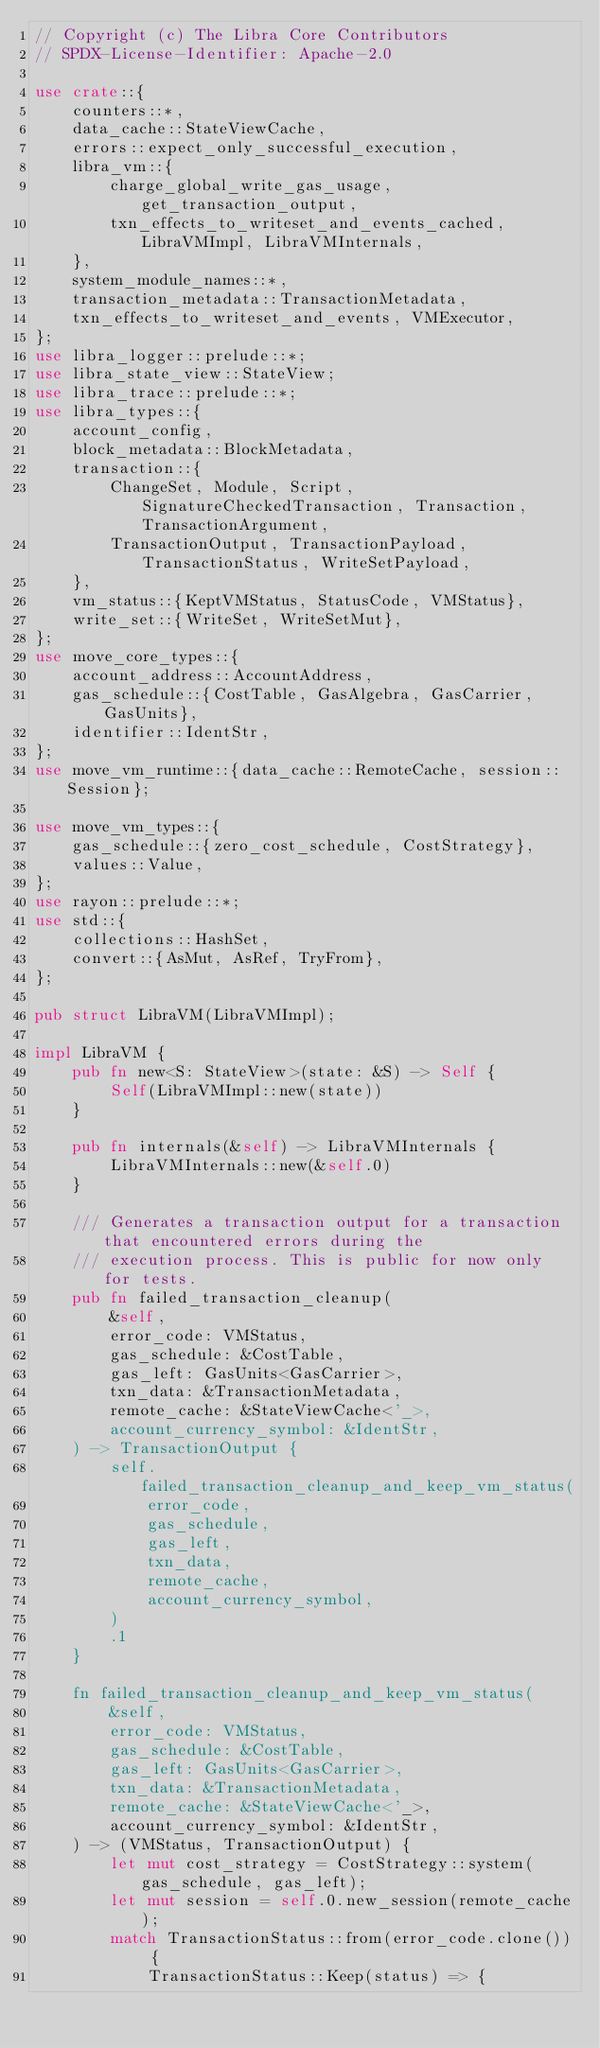Convert code to text. <code><loc_0><loc_0><loc_500><loc_500><_Rust_>// Copyright (c) The Libra Core Contributors
// SPDX-License-Identifier: Apache-2.0

use crate::{
    counters::*,
    data_cache::StateViewCache,
    errors::expect_only_successful_execution,
    libra_vm::{
        charge_global_write_gas_usage, get_transaction_output,
        txn_effects_to_writeset_and_events_cached, LibraVMImpl, LibraVMInternals,
    },
    system_module_names::*,
    transaction_metadata::TransactionMetadata,
    txn_effects_to_writeset_and_events, VMExecutor,
};
use libra_logger::prelude::*;
use libra_state_view::StateView;
use libra_trace::prelude::*;
use libra_types::{
    account_config,
    block_metadata::BlockMetadata,
    transaction::{
        ChangeSet, Module, Script, SignatureCheckedTransaction, Transaction, TransactionArgument,
        TransactionOutput, TransactionPayload, TransactionStatus, WriteSetPayload,
    },
    vm_status::{KeptVMStatus, StatusCode, VMStatus},
    write_set::{WriteSet, WriteSetMut},
};
use move_core_types::{
    account_address::AccountAddress,
    gas_schedule::{CostTable, GasAlgebra, GasCarrier, GasUnits},
    identifier::IdentStr,
};
use move_vm_runtime::{data_cache::RemoteCache, session::Session};

use move_vm_types::{
    gas_schedule::{zero_cost_schedule, CostStrategy},
    values::Value,
};
use rayon::prelude::*;
use std::{
    collections::HashSet,
    convert::{AsMut, AsRef, TryFrom},
};

pub struct LibraVM(LibraVMImpl);

impl LibraVM {
    pub fn new<S: StateView>(state: &S) -> Self {
        Self(LibraVMImpl::new(state))
    }

    pub fn internals(&self) -> LibraVMInternals {
        LibraVMInternals::new(&self.0)
    }

    /// Generates a transaction output for a transaction that encountered errors during the
    /// execution process. This is public for now only for tests.
    pub fn failed_transaction_cleanup(
        &self,
        error_code: VMStatus,
        gas_schedule: &CostTable,
        gas_left: GasUnits<GasCarrier>,
        txn_data: &TransactionMetadata,
        remote_cache: &StateViewCache<'_>,
        account_currency_symbol: &IdentStr,
    ) -> TransactionOutput {
        self.failed_transaction_cleanup_and_keep_vm_status(
            error_code,
            gas_schedule,
            gas_left,
            txn_data,
            remote_cache,
            account_currency_symbol,
        )
        .1
    }

    fn failed_transaction_cleanup_and_keep_vm_status(
        &self,
        error_code: VMStatus,
        gas_schedule: &CostTable,
        gas_left: GasUnits<GasCarrier>,
        txn_data: &TransactionMetadata,
        remote_cache: &StateViewCache<'_>,
        account_currency_symbol: &IdentStr,
    ) -> (VMStatus, TransactionOutput) {
        let mut cost_strategy = CostStrategy::system(gas_schedule, gas_left);
        let mut session = self.0.new_session(remote_cache);
        match TransactionStatus::from(error_code.clone()) {
            TransactionStatus::Keep(status) => {</code> 